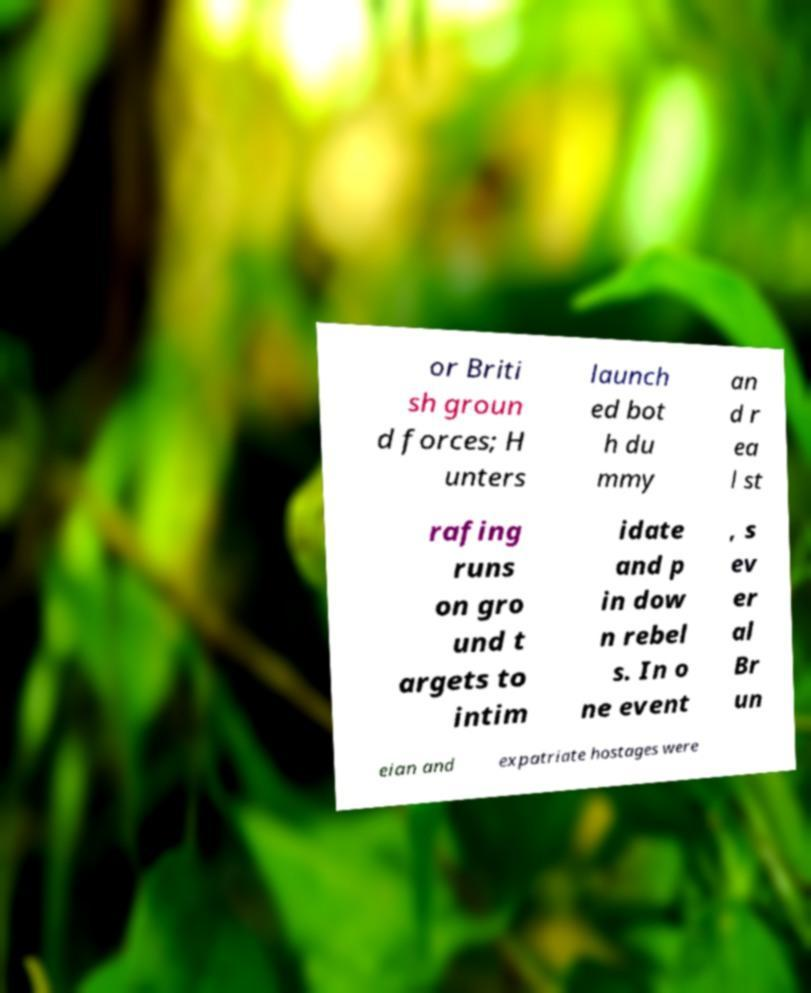For documentation purposes, I need the text within this image transcribed. Could you provide that? or Briti sh groun d forces; H unters launch ed bot h du mmy an d r ea l st rafing runs on gro und t argets to intim idate and p in dow n rebel s. In o ne event , s ev er al Br un eian and expatriate hostages were 